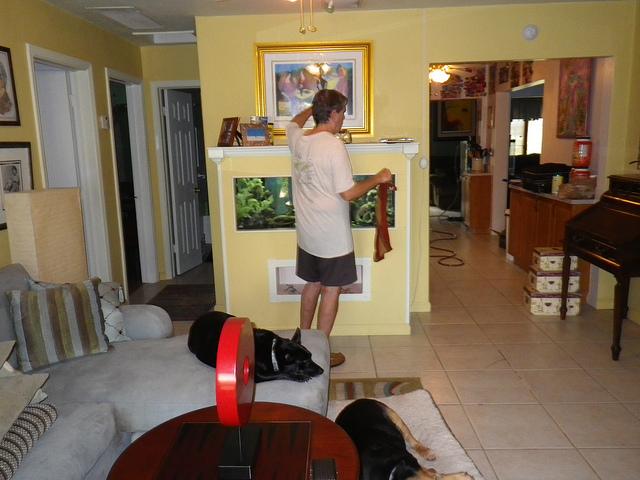What color is the paint on the wall?
Quick response, please. Yellow. What is the red object on the round wooden table?
Short answer required. Clock. Is this man cleaning?
Concise answer only. Yes. What is the dog laying on?
Write a very short answer. Couch. 